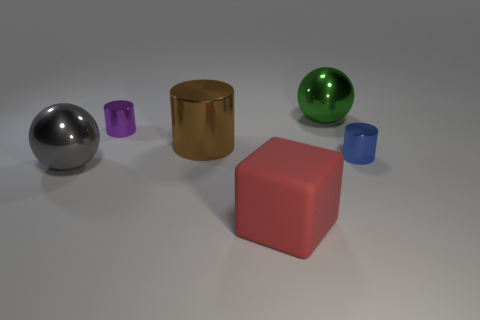Is there any other thing that is the same material as the block?
Make the answer very short. No. There is a brown metal object; does it have the same size as the shiny sphere to the right of the large brown thing?
Provide a succinct answer. Yes. What is the material of the large sphere behind the big metal ball that is in front of the tiny purple cylinder?
Offer a very short reply. Metal. Are there the same number of red matte cubes that are behind the block and tiny red blocks?
Make the answer very short. Yes. There is a metallic thing that is behind the brown metallic thing and right of the brown object; what is its size?
Your answer should be compact. Large. There is a large ball to the left of the shiny object that is behind the purple cylinder; what color is it?
Your answer should be very brief. Gray. What number of gray things are either tiny matte blocks or rubber blocks?
Provide a short and direct response. 0. There is a big metal thing that is on the right side of the tiny purple cylinder and in front of the purple metallic thing; what color is it?
Ensure brevity in your answer.  Brown. How many tiny things are gray rubber cylinders or red objects?
Your response must be concise. 0. The gray metallic thing that is the same shape as the big green thing is what size?
Make the answer very short. Large. 